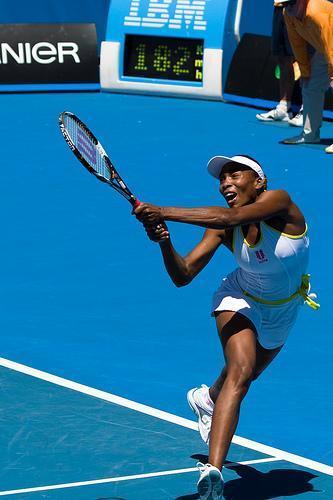How many tennis racquets are in the picture?
Give a very brief answer. 1. 